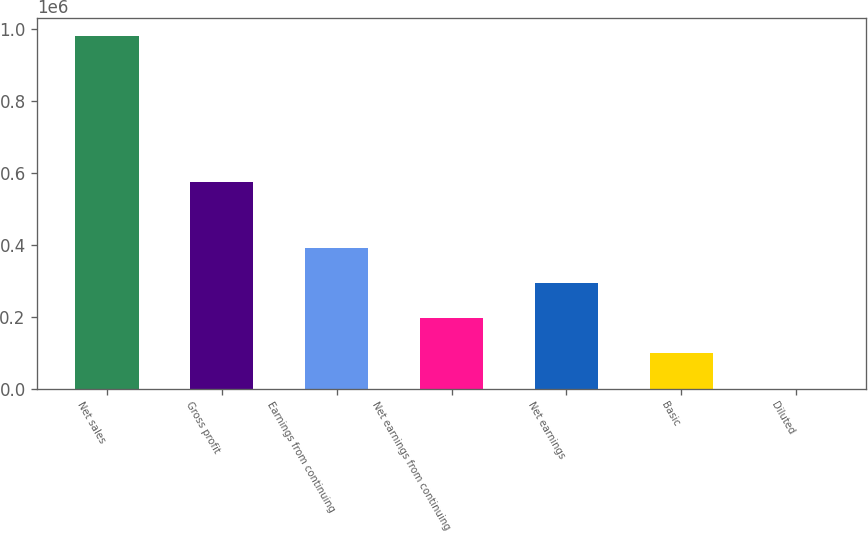<chart> <loc_0><loc_0><loc_500><loc_500><bar_chart><fcel>Net sales<fcel>Gross profit<fcel>Earnings from continuing<fcel>Net earnings from continuing<fcel>Net earnings<fcel>Basic<fcel>Diluted<nl><fcel>981384<fcel>575745<fcel>392554<fcel>196278<fcel>294416<fcel>98139.4<fcel>1.09<nl></chart> 